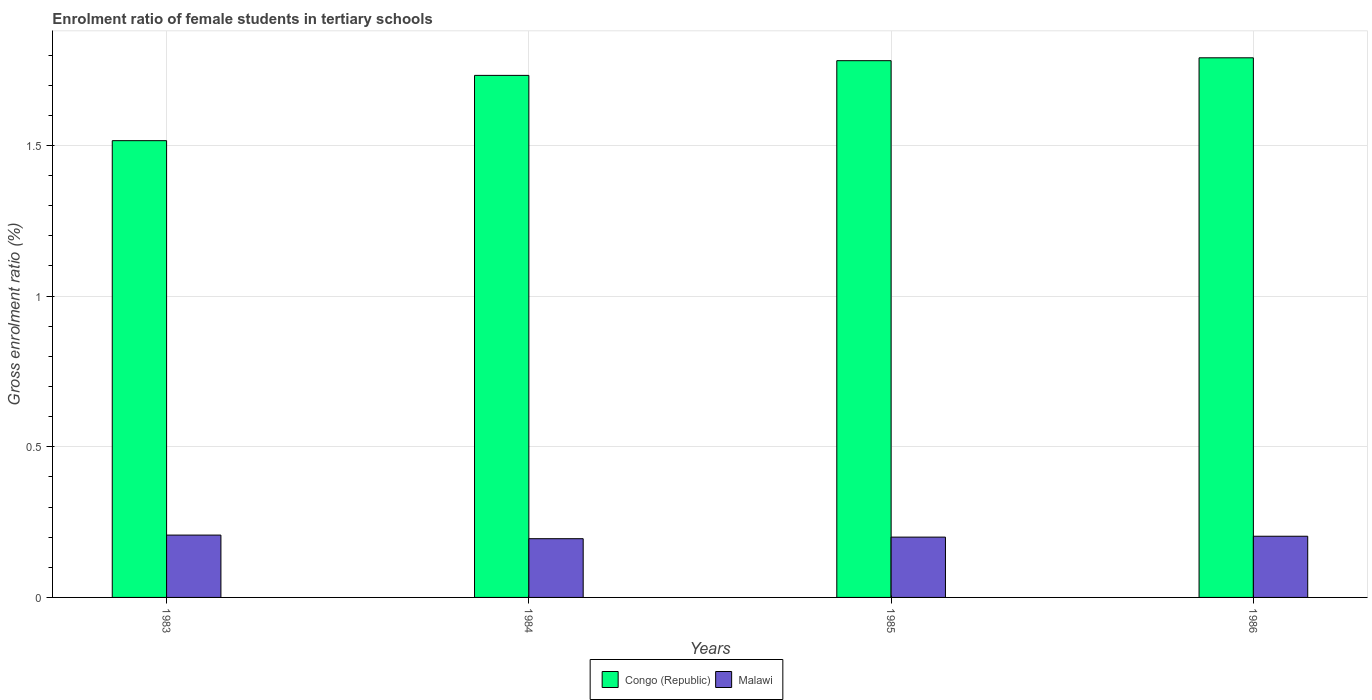What is the label of the 4th group of bars from the left?
Provide a short and direct response. 1986. What is the enrolment ratio of female students in tertiary schools in Congo (Republic) in 1986?
Provide a succinct answer. 1.79. Across all years, what is the maximum enrolment ratio of female students in tertiary schools in Malawi?
Ensure brevity in your answer.  0.21. Across all years, what is the minimum enrolment ratio of female students in tertiary schools in Congo (Republic)?
Provide a succinct answer. 1.52. In which year was the enrolment ratio of female students in tertiary schools in Malawi maximum?
Keep it short and to the point. 1983. What is the total enrolment ratio of female students in tertiary schools in Congo (Republic) in the graph?
Your answer should be very brief. 6.82. What is the difference between the enrolment ratio of female students in tertiary schools in Malawi in 1984 and that in 1985?
Keep it short and to the point. -0.01. What is the difference between the enrolment ratio of female students in tertiary schools in Congo (Republic) in 1986 and the enrolment ratio of female students in tertiary schools in Malawi in 1984?
Give a very brief answer. 1.6. What is the average enrolment ratio of female students in tertiary schools in Congo (Republic) per year?
Offer a terse response. 1.71. In the year 1986, what is the difference between the enrolment ratio of female students in tertiary schools in Congo (Republic) and enrolment ratio of female students in tertiary schools in Malawi?
Your response must be concise. 1.59. What is the ratio of the enrolment ratio of female students in tertiary schools in Congo (Republic) in 1983 to that in 1986?
Ensure brevity in your answer.  0.85. Is the enrolment ratio of female students in tertiary schools in Malawi in 1984 less than that in 1986?
Your answer should be very brief. Yes. What is the difference between the highest and the second highest enrolment ratio of female students in tertiary schools in Malawi?
Offer a terse response. 0. What is the difference between the highest and the lowest enrolment ratio of female students in tertiary schools in Congo (Republic)?
Your answer should be very brief. 0.27. Is the sum of the enrolment ratio of female students in tertiary schools in Malawi in 1984 and 1986 greater than the maximum enrolment ratio of female students in tertiary schools in Congo (Republic) across all years?
Give a very brief answer. No. What does the 1st bar from the left in 1985 represents?
Ensure brevity in your answer.  Congo (Republic). What does the 1st bar from the right in 1984 represents?
Your answer should be compact. Malawi. How many bars are there?
Your response must be concise. 8. Are all the bars in the graph horizontal?
Give a very brief answer. No. What is the difference between two consecutive major ticks on the Y-axis?
Offer a terse response. 0.5. Are the values on the major ticks of Y-axis written in scientific E-notation?
Ensure brevity in your answer.  No. How many legend labels are there?
Keep it short and to the point. 2. What is the title of the graph?
Ensure brevity in your answer.  Enrolment ratio of female students in tertiary schools. Does "Suriname" appear as one of the legend labels in the graph?
Your answer should be very brief. No. What is the label or title of the Y-axis?
Give a very brief answer. Gross enrolment ratio (%). What is the Gross enrolment ratio (%) of Congo (Republic) in 1983?
Give a very brief answer. 1.52. What is the Gross enrolment ratio (%) in Malawi in 1983?
Keep it short and to the point. 0.21. What is the Gross enrolment ratio (%) in Congo (Republic) in 1984?
Provide a succinct answer. 1.73. What is the Gross enrolment ratio (%) of Malawi in 1984?
Ensure brevity in your answer.  0.19. What is the Gross enrolment ratio (%) of Congo (Republic) in 1985?
Give a very brief answer. 1.78. What is the Gross enrolment ratio (%) in Malawi in 1985?
Ensure brevity in your answer.  0.2. What is the Gross enrolment ratio (%) in Congo (Republic) in 1986?
Provide a succinct answer. 1.79. What is the Gross enrolment ratio (%) of Malawi in 1986?
Give a very brief answer. 0.2. Across all years, what is the maximum Gross enrolment ratio (%) in Congo (Republic)?
Offer a very short reply. 1.79. Across all years, what is the maximum Gross enrolment ratio (%) of Malawi?
Your answer should be very brief. 0.21. Across all years, what is the minimum Gross enrolment ratio (%) in Congo (Republic)?
Give a very brief answer. 1.52. Across all years, what is the minimum Gross enrolment ratio (%) in Malawi?
Your answer should be very brief. 0.19. What is the total Gross enrolment ratio (%) of Congo (Republic) in the graph?
Provide a short and direct response. 6.82. What is the total Gross enrolment ratio (%) of Malawi in the graph?
Your answer should be compact. 0.8. What is the difference between the Gross enrolment ratio (%) in Congo (Republic) in 1983 and that in 1984?
Make the answer very short. -0.22. What is the difference between the Gross enrolment ratio (%) of Malawi in 1983 and that in 1984?
Give a very brief answer. 0.01. What is the difference between the Gross enrolment ratio (%) of Congo (Republic) in 1983 and that in 1985?
Provide a succinct answer. -0.27. What is the difference between the Gross enrolment ratio (%) in Malawi in 1983 and that in 1985?
Offer a very short reply. 0.01. What is the difference between the Gross enrolment ratio (%) of Congo (Republic) in 1983 and that in 1986?
Make the answer very short. -0.27. What is the difference between the Gross enrolment ratio (%) in Malawi in 1983 and that in 1986?
Your answer should be very brief. 0. What is the difference between the Gross enrolment ratio (%) of Congo (Republic) in 1984 and that in 1985?
Ensure brevity in your answer.  -0.05. What is the difference between the Gross enrolment ratio (%) in Malawi in 1984 and that in 1985?
Offer a terse response. -0.01. What is the difference between the Gross enrolment ratio (%) of Congo (Republic) in 1984 and that in 1986?
Offer a terse response. -0.06. What is the difference between the Gross enrolment ratio (%) in Malawi in 1984 and that in 1986?
Your answer should be compact. -0.01. What is the difference between the Gross enrolment ratio (%) in Congo (Republic) in 1985 and that in 1986?
Provide a succinct answer. -0.01. What is the difference between the Gross enrolment ratio (%) of Malawi in 1985 and that in 1986?
Provide a succinct answer. -0. What is the difference between the Gross enrolment ratio (%) in Congo (Republic) in 1983 and the Gross enrolment ratio (%) in Malawi in 1984?
Ensure brevity in your answer.  1.32. What is the difference between the Gross enrolment ratio (%) of Congo (Republic) in 1983 and the Gross enrolment ratio (%) of Malawi in 1985?
Your answer should be very brief. 1.32. What is the difference between the Gross enrolment ratio (%) in Congo (Republic) in 1983 and the Gross enrolment ratio (%) in Malawi in 1986?
Keep it short and to the point. 1.31. What is the difference between the Gross enrolment ratio (%) in Congo (Republic) in 1984 and the Gross enrolment ratio (%) in Malawi in 1985?
Your answer should be compact. 1.53. What is the difference between the Gross enrolment ratio (%) in Congo (Republic) in 1984 and the Gross enrolment ratio (%) in Malawi in 1986?
Offer a terse response. 1.53. What is the difference between the Gross enrolment ratio (%) in Congo (Republic) in 1985 and the Gross enrolment ratio (%) in Malawi in 1986?
Make the answer very short. 1.58. What is the average Gross enrolment ratio (%) of Congo (Republic) per year?
Offer a very short reply. 1.71. What is the average Gross enrolment ratio (%) in Malawi per year?
Provide a short and direct response. 0.2. In the year 1983, what is the difference between the Gross enrolment ratio (%) in Congo (Republic) and Gross enrolment ratio (%) in Malawi?
Offer a very short reply. 1.31. In the year 1984, what is the difference between the Gross enrolment ratio (%) in Congo (Republic) and Gross enrolment ratio (%) in Malawi?
Offer a terse response. 1.54. In the year 1985, what is the difference between the Gross enrolment ratio (%) of Congo (Republic) and Gross enrolment ratio (%) of Malawi?
Keep it short and to the point. 1.58. In the year 1986, what is the difference between the Gross enrolment ratio (%) of Congo (Republic) and Gross enrolment ratio (%) of Malawi?
Your answer should be compact. 1.59. What is the ratio of the Gross enrolment ratio (%) of Malawi in 1983 to that in 1984?
Keep it short and to the point. 1.06. What is the ratio of the Gross enrolment ratio (%) of Congo (Republic) in 1983 to that in 1985?
Give a very brief answer. 0.85. What is the ratio of the Gross enrolment ratio (%) in Malawi in 1983 to that in 1985?
Give a very brief answer. 1.03. What is the ratio of the Gross enrolment ratio (%) in Congo (Republic) in 1983 to that in 1986?
Your answer should be very brief. 0.85. What is the ratio of the Gross enrolment ratio (%) in Congo (Republic) in 1984 to that in 1985?
Give a very brief answer. 0.97. What is the ratio of the Gross enrolment ratio (%) of Malawi in 1984 to that in 1985?
Provide a short and direct response. 0.97. What is the ratio of the Gross enrolment ratio (%) in Congo (Republic) in 1984 to that in 1986?
Give a very brief answer. 0.97. What is the ratio of the Gross enrolment ratio (%) of Malawi in 1984 to that in 1986?
Your answer should be compact. 0.96. What is the ratio of the Gross enrolment ratio (%) in Malawi in 1985 to that in 1986?
Ensure brevity in your answer.  0.99. What is the difference between the highest and the second highest Gross enrolment ratio (%) in Congo (Republic)?
Your response must be concise. 0.01. What is the difference between the highest and the second highest Gross enrolment ratio (%) in Malawi?
Provide a short and direct response. 0. What is the difference between the highest and the lowest Gross enrolment ratio (%) of Congo (Republic)?
Offer a very short reply. 0.27. What is the difference between the highest and the lowest Gross enrolment ratio (%) of Malawi?
Keep it short and to the point. 0.01. 